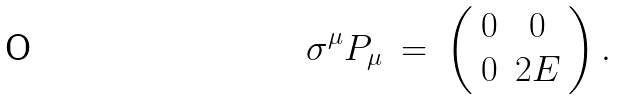Convert formula to latex. <formula><loc_0><loc_0><loc_500><loc_500>\sigma ^ { \mu } P _ { \mu } \ = \ \left ( \begin{array} { c c } 0 & 0 \\ 0 & 2 E \end{array} \right ) .</formula> 